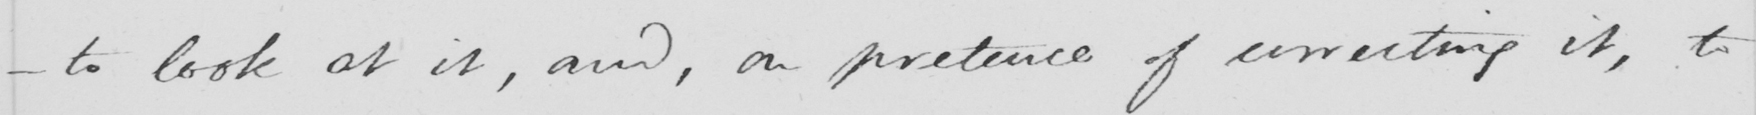Can you tell me what this handwritten text says? _  to look at it , and , on pretence of correcting it , to 